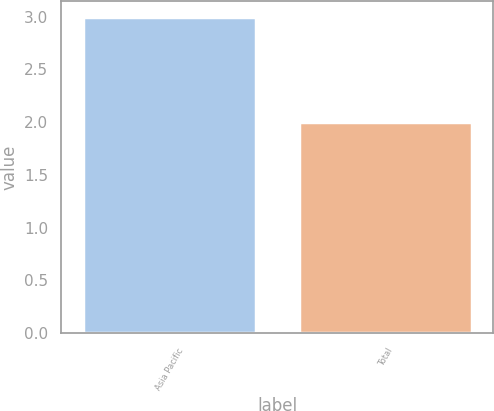<chart> <loc_0><loc_0><loc_500><loc_500><bar_chart><fcel>Asia Pacific<fcel>Total<nl><fcel>3<fcel>2<nl></chart> 